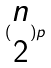<formula> <loc_0><loc_0><loc_500><loc_500>( \begin{matrix} n \\ 2 \end{matrix} ) p</formula> 